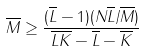Convert formula to latex. <formula><loc_0><loc_0><loc_500><loc_500>\overline { M } \geq \frac { ( \overline { L } - 1 ) ( N \overline { L } / \overline { M } ) } { \overline { L } \overline { K } - \overline { L } - \overline { K } }</formula> 